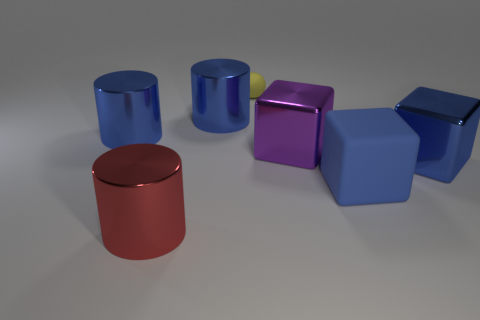Add 2 blue metal cylinders. How many objects exist? 9 Subtract all cylinders. How many objects are left? 4 Subtract all tiny yellow spheres. Subtract all tiny objects. How many objects are left? 5 Add 3 blue metallic objects. How many blue metallic objects are left? 6 Add 2 rubber blocks. How many rubber blocks exist? 3 Subtract 0 brown cubes. How many objects are left? 7 